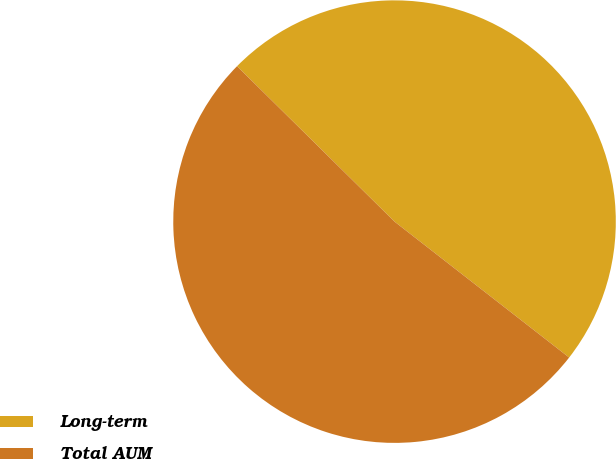Convert chart to OTSL. <chart><loc_0><loc_0><loc_500><loc_500><pie_chart><fcel>Long-term<fcel>Total AUM<nl><fcel>48.13%<fcel>51.87%<nl></chart> 